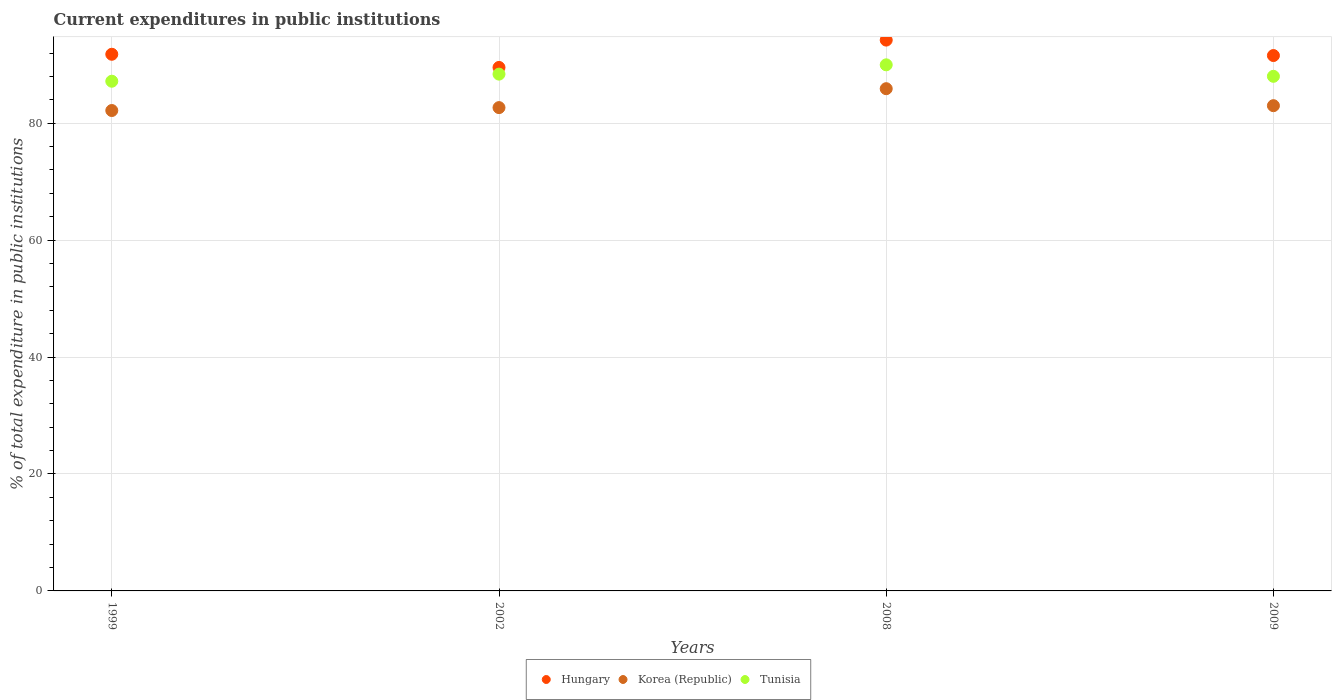Is the number of dotlines equal to the number of legend labels?
Ensure brevity in your answer.  Yes. What is the current expenditures in public institutions in Korea (Republic) in 2009?
Offer a very short reply. 83. Across all years, what is the maximum current expenditures in public institutions in Hungary?
Offer a terse response. 94.22. Across all years, what is the minimum current expenditures in public institutions in Hungary?
Provide a succinct answer. 89.54. What is the total current expenditures in public institutions in Tunisia in the graph?
Give a very brief answer. 353.6. What is the difference between the current expenditures in public institutions in Tunisia in 2002 and that in 2008?
Offer a very short reply. -1.59. What is the difference between the current expenditures in public institutions in Tunisia in 1999 and the current expenditures in public institutions in Korea (Republic) in 2009?
Give a very brief answer. 4.18. What is the average current expenditures in public institutions in Korea (Republic) per year?
Offer a very short reply. 83.44. In the year 1999, what is the difference between the current expenditures in public institutions in Korea (Republic) and current expenditures in public institutions in Tunisia?
Your answer should be very brief. -5.01. In how many years, is the current expenditures in public institutions in Korea (Republic) greater than 44 %?
Ensure brevity in your answer.  4. What is the ratio of the current expenditures in public institutions in Hungary in 1999 to that in 2009?
Provide a succinct answer. 1. What is the difference between the highest and the second highest current expenditures in public institutions in Hungary?
Provide a succinct answer. 2.42. What is the difference between the highest and the lowest current expenditures in public institutions in Tunisia?
Make the answer very short. 2.81. In how many years, is the current expenditures in public institutions in Hungary greater than the average current expenditures in public institutions in Hungary taken over all years?
Provide a short and direct response. 2. Is the sum of the current expenditures in public institutions in Hungary in 2008 and 2009 greater than the maximum current expenditures in public institutions in Tunisia across all years?
Your answer should be compact. Yes. Is it the case that in every year, the sum of the current expenditures in public institutions in Hungary and current expenditures in public institutions in Tunisia  is greater than the current expenditures in public institutions in Korea (Republic)?
Keep it short and to the point. Yes. Does the current expenditures in public institutions in Korea (Republic) monotonically increase over the years?
Provide a short and direct response. No. Is the current expenditures in public institutions in Korea (Republic) strictly greater than the current expenditures in public institutions in Hungary over the years?
Offer a very short reply. No. How many years are there in the graph?
Your answer should be very brief. 4. Does the graph contain grids?
Provide a succinct answer. Yes. How are the legend labels stacked?
Make the answer very short. Horizontal. What is the title of the graph?
Your answer should be compact. Current expenditures in public institutions. What is the label or title of the X-axis?
Provide a short and direct response. Years. What is the label or title of the Y-axis?
Your answer should be compact. % of total expenditure in public institutions. What is the % of total expenditure in public institutions of Hungary in 1999?
Ensure brevity in your answer.  91.8. What is the % of total expenditure in public institutions of Korea (Republic) in 1999?
Your answer should be very brief. 82.17. What is the % of total expenditure in public institutions of Tunisia in 1999?
Keep it short and to the point. 87.18. What is the % of total expenditure in public institutions in Hungary in 2002?
Your answer should be very brief. 89.54. What is the % of total expenditure in public institutions in Korea (Republic) in 2002?
Make the answer very short. 82.67. What is the % of total expenditure in public institutions in Tunisia in 2002?
Provide a short and direct response. 88.4. What is the % of total expenditure in public institutions in Hungary in 2008?
Your response must be concise. 94.22. What is the % of total expenditure in public institutions of Korea (Republic) in 2008?
Offer a very short reply. 85.91. What is the % of total expenditure in public institutions in Tunisia in 2008?
Make the answer very short. 89.99. What is the % of total expenditure in public institutions of Hungary in 2009?
Keep it short and to the point. 91.58. What is the % of total expenditure in public institutions in Korea (Republic) in 2009?
Your answer should be compact. 83. What is the % of total expenditure in public institutions in Tunisia in 2009?
Offer a very short reply. 88.02. Across all years, what is the maximum % of total expenditure in public institutions in Hungary?
Make the answer very short. 94.22. Across all years, what is the maximum % of total expenditure in public institutions of Korea (Republic)?
Make the answer very short. 85.91. Across all years, what is the maximum % of total expenditure in public institutions in Tunisia?
Offer a terse response. 89.99. Across all years, what is the minimum % of total expenditure in public institutions in Hungary?
Your response must be concise. 89.54. Across all years, what is the minimum % of total expenditure in public institutions of Korea (Republic)?
Provide a short and direct response. 82.17. Across all years, what is the minimum % of total expenditure in public institutions in Tunisia?
Offer a terse response. 87.18. What is the total % of total expenditure in public institutions in Hungary in the graph?
Give a very brief answer. 367.13. What is the total % of total expenditure in public institutions in Korea (Republic) in the graph?
Make the answer very short. 333.76. What is the total % of total expenditure in public institutions of Tunisia in the graph?
Your answer should be compact. 353.6. What is the difference between the % of total expenditure in public institutions in Hungary in 1999 and that in 2002?
Ensure brevity in your answer.  2.25. What is the difference between the % of total expenditure in public institutions in Korea (Republic) in 1999 and that in 2002?
Keep it short and to the point. -0.5. What is the difference between the % of total expenditure in public institutions in Tunisia in 1999 and that in 2002?
Keep it short and to the point. -1.22. What is the difference between the % of total expenditure in public institutions in Hungary in 1999 and that in 2008?
Your answer should be compact. -2.42. What is the difference between the % of total expenditure in public institutions in Korea (Republic) in 1999 and that in 2008?
Ensure brevity in your answer.  -3.73. What is the difference between the % of total expenditure in public institutions of Tunisia in 1999 and that in 2008?
Give a very brief answer. -2.81. What is the difference between the % of total expenditure in public institutions of Hungary in 1999 and that in 2009?
Your answer should be compact. 0.22. What is the difference between the % of total expenditure in public institutions of Korea (Republic) in 1999 and that in 2009?
Offer a terse response. -0.83. What is the difference between the % of total expenditure in public institutions in Tunisia in 1999 and that in 2009?
Provide a succinct answer. -0.84. What is the difference between the % of total expenditure in public institutions of Hungary in 2002 and that in 2008?
Your response must be concise. -4.68. What is the difference between the % of total expenditure in public institutions in Korea (Republic) in 2002 and that in 2008?
Give a very brief answer. -3.24. What is the difference between the % of total expenditure in public institutions in Tunisia in 2002 and that in 2008?
Keep it short and to the point. -1.59. What is the difference between the % of total expenditure in public institutions of Hungary in 2002 and that in 2009?
Ensure brevity in your answer.  -2.04. What is the difference between the % of total expenditure in public institutions in Korea (Republic) in 2002 and that in 2009?
Offer a very short reply. -0.33. What is the difference between the % of total expenditure in public institutions in Tunisia in 2002 and that in 2009?
Ensure brevity in your answer.  0.37. What is the difference between the % of total expenditure in public institutions in Hungary in 2008 and that in 2009?
Offer a terse response. 2.64. What is the difference between the % of total expenditure in public institutions of Korea (Republic) in 2008 and that in 2009?
Your response must be concise. 2.91. What is the difference between the % of total expenditure in public institutions in Tunisia in 2008 and that in 2009?
Your answer should be compact. 1.97. What is the difference between the % of total expenditure in public institutions in Hungary in 1999 and the % of total expenditure in public institutions in Korea (Republic) in 2002?
Keep it short and to the point. 9.12. What is the difference between the % of total expenditure in public institutions of Hungary in 1999 and the % of total expenditure in public institutions of Tunisia in 2002?
Provide a short and direct response. 3.4. What is the difference between the % of total expenditure in public institutions in Korea (Republic) in 1999 and the % of total expenditure in public institutions in Tunisia in 2002?
Provide a succinct answer. -6.23. What is the difference between the % of total expenditure in public institutions in Hungary in 1999 and the % of total expenditure in public institutions in Korea (Republic) in 2008?
Offer a terse response. 5.89. What is the difference between the % of total expenditure in public institutions of Hungary in 1999 and the % of total expenditure in public institutions of Tunisia in 2008?
Your response must be concise. 1.81. What is the difference between the % of total expenditure in public institutions in Korea (Republic) in 1999 and the % of total expenditure in public institutions in Tunisia in 2008?
Keep it short and to the point. -7.82. What is the difference between the % of total expenditure in public institutions in Hungary in 1999 and the % of total expenditure in public institutions in Korea (Republic) in 2009?
Make the answer very short. 8.79. What is the difference between the % of total expenditure in public institutions of Hungary in 1999 and the % of total expenditure in public institutions of Tunisia in 2009?
Your response must be concise. 3.77. What is the difference between the % of total expenditure in public institutions in Korea (Republic) in 1999 and the % of total expenditure in public institutions in Tunisia in 2009?
Offer a terse response. -5.85. What is the difference between the % of total expenditure in public institutions in Hungary in 2002 and the % of total expenditure in public institutions in Korea (Republic) in 2008?
Provide a succinct answer. 3.63. What is the difference between the % of total expenditure in public institutions in Hungary in 2002 and the % of total expenditure in public institutions in Tunisia in 2008?
Make the answer very short. -0.45. What is the difference between the % of total expenditure in public institutions of Korea (Republic) in 2002 and the % of total expenditure in public institutions of Tunisia in 2008?
Provide a short and direct response. -7.32. What is the difference between the % of total expenditure in public institutions of Hungary in 2002 and the % of total expenditure in public institutions of Korea (Republic) in 2009?
Provide a succinct answer. 6.54. What is the difference between the % of total expenditure in public institutions of Hungary in 2002 and the % of total expenditure in public institutions of Tunisia in 2009?
Make the answer very short. 1.52. What is the difference between the % of total expenditure in public institutions of Korea (Republic) in 2002 and the % of total expenditure in public institutions of Tunisia in 2009?
Provide a short and direct response. -5.35. What is the difference between the % of total expenditure in public institutions of Hungary in 2008 and the % of total expenditure in public institutions of Korea (Republic) in 2009?
Offer a terse response. 11.22. What is the difference between the % of total expenditure in public institutions of Hungary in 2008 and the % of total expenditure in public institutions of Tunisia in 2009?
Offer a terse response. 6.2. What is the difference between the % of total expenditure in public institutions in Korea (Republic) in 2008 and the % of total expenditure in public institutions in Tunisia in 2009?
Give a very brief answer. -2.12. What is the average % of total expenditure in public institutions in Hungary per year?
Give a very brief answer. 91.78. What is the average % of total expenditure in public institutions of Korea (Republic) per year?
Keep it short and to the point. 83.44. What is the average % of total expenditure in public institutions of Tunisia per year?
Ensure brevity in your answer.  88.4. In the year 1999, what is the difference between the % of total expenditure in public institutions of Hungary and % of total expenditure in public institutions of Korea (Republic)?
Keep it short and to the point. 9.62. In the year 1999, what is the difference between the % of total expenditure in public institutions in Hungary and % of total expenditure in public institutions in Tunisia?
Offer a terse response. 4.61. In the year 1999, what is the difference between the % of total expenditure in public institutions of Korea (Republic) and % of total expenditure in public institutions of Tunisia?
Offer a terse response. -5.01. In the year 2002, what is the difference between the % of total expenditure in public institutions in Hungary and % of total expenditure in public institutions in Korea (Republic)?
Give a very brief answer. 6.87. In the year 2002, what is the difference between the % of total expenditure in public institutions in Hungary and % of total expenditure in public institutions in Tunisia?
Give a very brief answer. 1.14. In the year 2002, what is the difference between the % of total expenditure in public institutions in Korea (Republic) and % of total expenditure in public institutions in Tunisia?
Provide a short and direct response. -5.73. In the year 2008, what is the difference between the % of total expenditure in public institutions in Hungary and % of total expenditure in public institutions in Korea (Republic)?
Offer a very short reply. 8.31. In the year 2008, what is the difference between the % of total expenditure in public institutions in Hungary and % of total expenditure in public institutions in Tunisia?
Give a very brief answer. 4.23. In the year 2008, what is the difference between the % of total expenditure in public institutions of Korea (Republic) and % of total expenditure in public institutions of Tunisia?
Offer a very short reply. -4.08. In the year 2009, what is the difference between the % of total expenditure in public institutions in Hungary and % of total expenditure in public institutions in Korea (Republic)?
Provide a short and direct response. 8.58. In the year 2009, what is the difference between the % of total expenditure in public institutions of Hungary and % of total expenditure in public institutions of Tunisia?
Your response must be concise. 3.55. In the year 2009, what is the difference between the % of total expenditure in public institutions in Korea (Republic) and % of total expenditure in public institutions in Tunisia?
Provide a short and direct response. -5.02. What is the ratio of the % of total expenditure in public institutions of Hungary in 1999 to that in 2002?
Your answer should be compact. 1.03. What is the ratio of the % of total expenditure in public institutions in Tunisia in 1999 to that in 2002?
Make the answer very short. 0.99. What is the ratio of the % of total expenditure in public institutions of Hungary in 1999 to that in 2008?
Provide a short and direct response. 0.97. What is the ratio of the % of total expenditure in public institutions in Korea (Republic) in 1999 to that in 2008?
Offer a very short reply. 0.96. What is the ratio of the % of total expenditure in public institutions of Tunisia in 1999 to that in 2008?
Keep it short and to the point. 0.97. What is the ratio of the % of total expenditure in public institutions of Hungary in 1999 to that in 2009?
Provide a short and direct response. 1. What is the ratio of the % of total expenditure in public institutions of Hungary in 2002 to that in 2008?
Your response must be concise. 0.95. What is the ratio of the % of total expenditure in public institutions in Korea (Republic) in 2002 to that in 2008?
Offer a terse response. 0.96. What is the ratio of the % of total expenditure in public institutions in Tunisia in 2002 to that in 2008?
Provide a short and direct response. 0.98. What is the ratio of the % of total expenditure in public institutions in Hungary in 2002 to that in 2009?
Ensure brevity in your answer.  0.98. What is the ratio of the % of total expenditure in public institutions of Korea (Republic) in 2002 to that in 2009?
Provide a short and direct response. 1. What is the ratio of the % of total expenditure in public institutions in Hungary in 2008 to that in 2009?
Provide a short and direct response. 1.03. What is the ratio of the % of total expenditure in public institutions of Korea (Republic) in 2008 to that in 2009?
Provide a short and direct response. 1.03. What is the ratio of the % of total expenditure in public institutions of Tunisia in 2008 to that in 2009?
Make the answer very short. 1.02. What is the difference between the highest and the second highest % of total expenditure in public institutions of Hungary?
Make the answer very short. 2.42. What is the difference between the highest and the second highest % of total expenditure in public institutions of Korea (Republic)?
Provide a succinct answer. 2.91. What is the difference between the highest and the second highest % of total expenditure in public institutions of Tunisia?
Provide a short and direct response. 1.59. What is the difference between the highest and the lowest % of total expenditure in public institutions in Hungary?
Your response must be concise. 4.68. What is the difference between the highest and the lowest % of total expenditure in public institutions in Korea (Republic)?
Provide a succinct answer. 3.73. What is the difference between the highest and the lowest % of total expenditure in public institutions in Tunisia?
Make the answer very short. 2.81. 